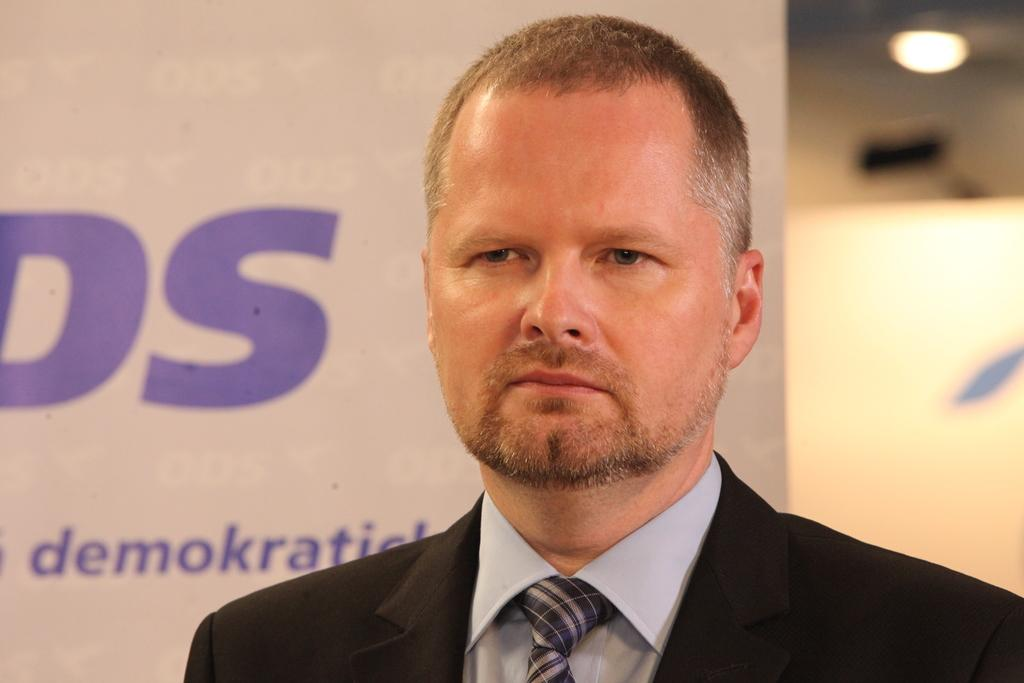What is the main subject in the foreground of the image? There is a man in the foreground of the image. What is the man wearing? The man is wearing a black suit. What can be seen in the background of the image? There is a board, a wall, and a light in the background of the image. Can you describe the setting of the image? The image may have been taken in a hall. Can you hear the man laughing in the image? There is no sound in the image, so it is not possible to hear the man laughing. 